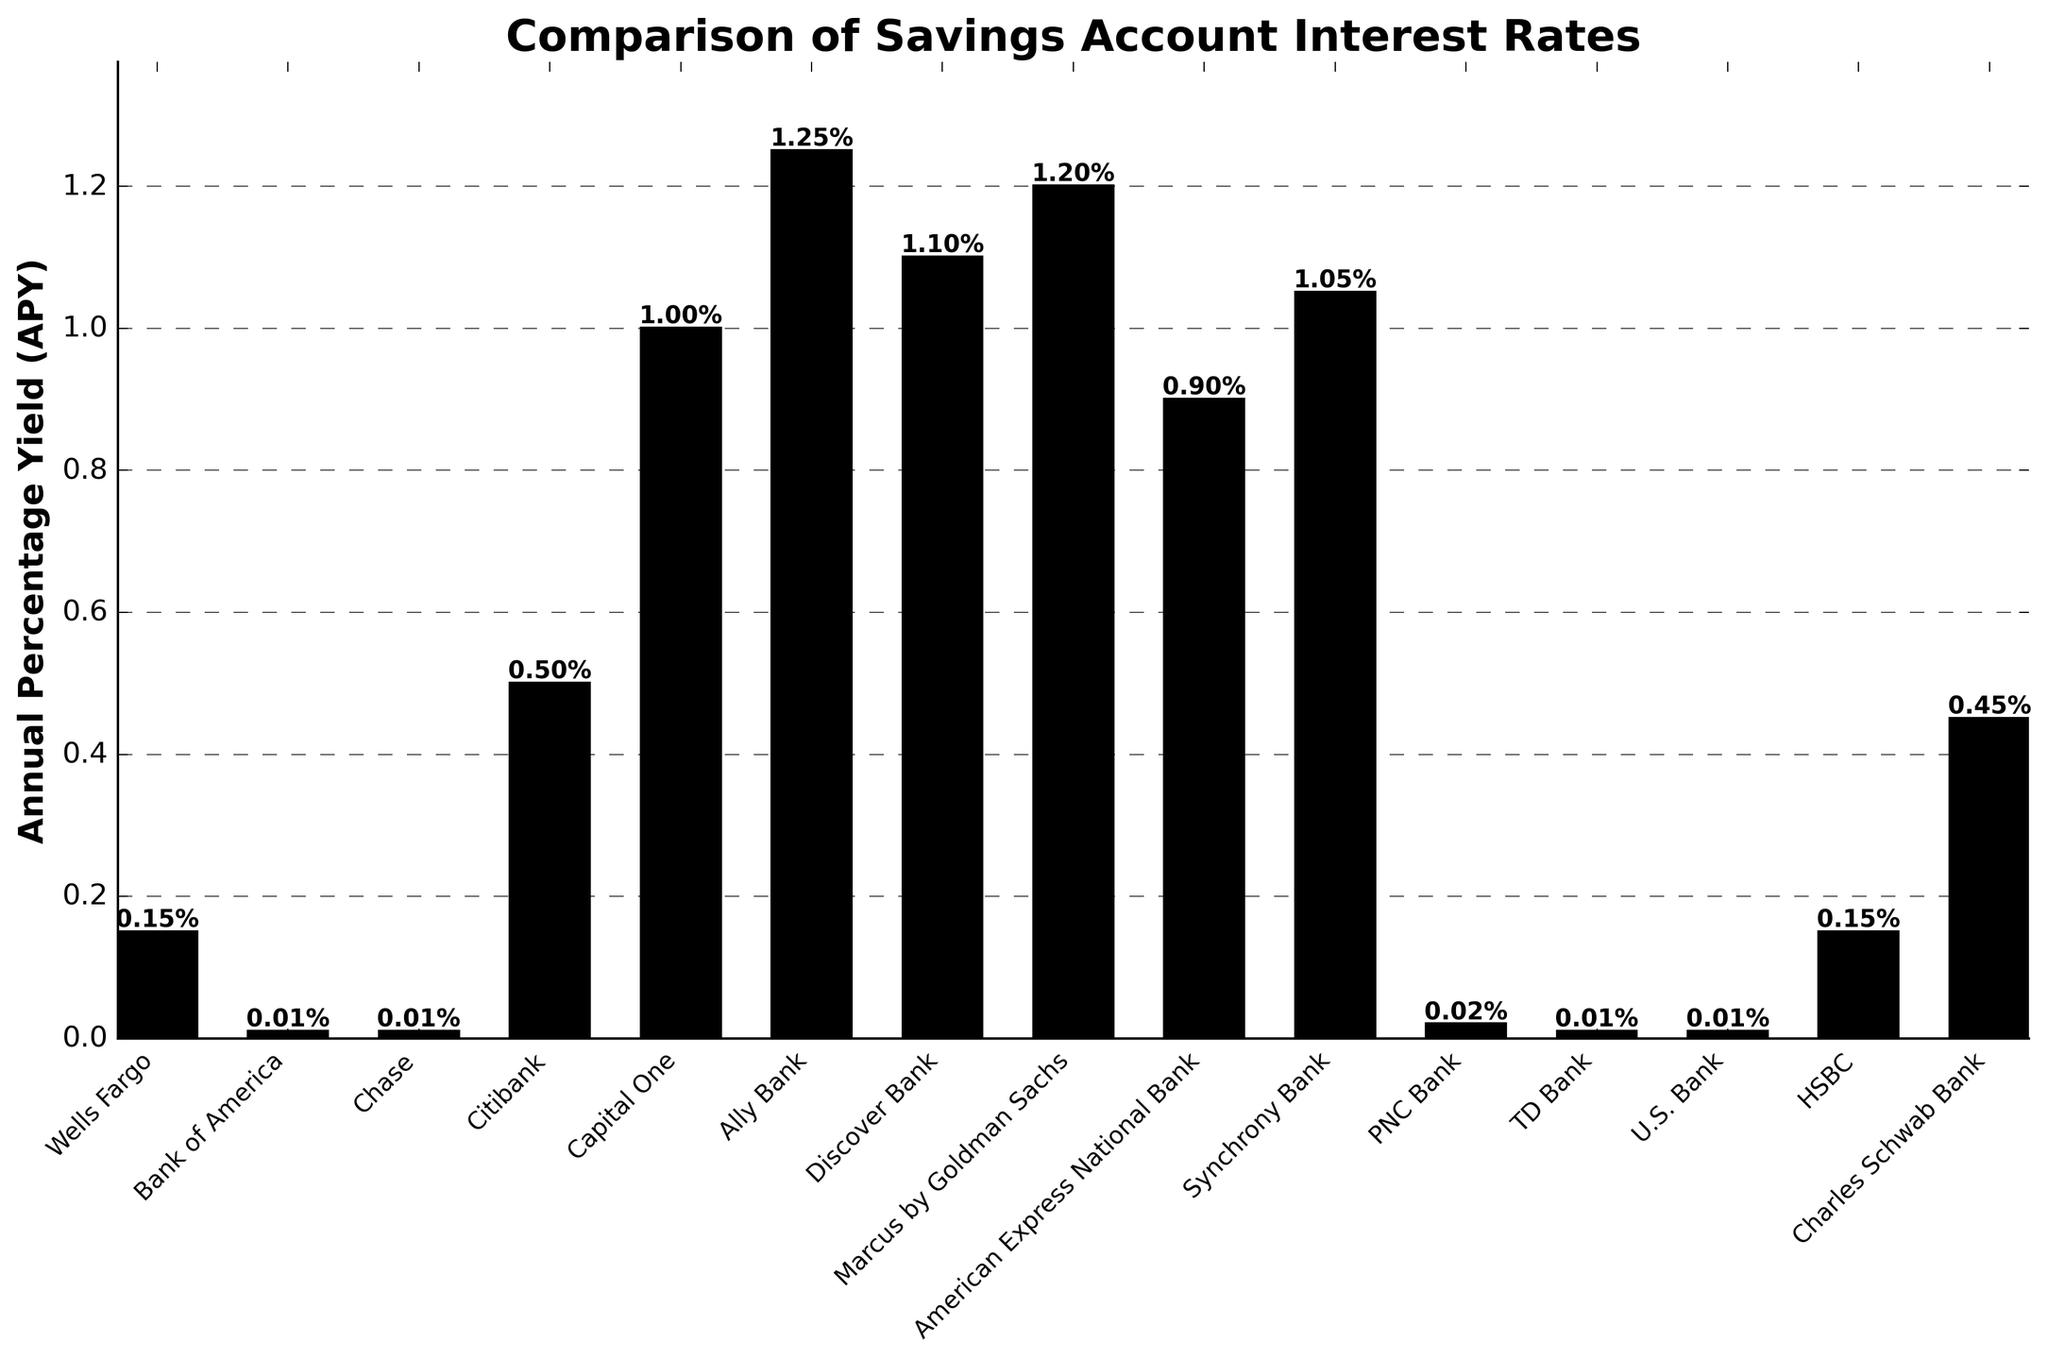What is the range of the Annual Percentage Yield (APY) among all the banks? To find the range, identify the highest and lowest APY values in the chart. The highest APY is 1.25% (Ally Bank), and the lowest is 0.01% (Bank of America, Chase, TD Bank, U.S. Bank). Subtract the lowest value from the highest value to get the range: 1.25% - 0.01% = 1.24%.
Answer: 1.24% Which bank offers the highest APY according to the chart? Look for the tallest bar on the figure which represents the highest APY. The tallest bar corresponds to Ally Bank with an APY of 1.25%.
Answer: Ally Bank How many banks have an APY lower than 0.10%? Identify the banks with bars representing APYs lower than 0.10%. Bank of America, Chase, TD Bank, and U.S. Bank all have an APY of 0.01%. PNC Bank has an APY of 0.02%. Therefore, there are 5 banks with an APY lower than 0.10%.
Answer: 5 What is the average APY of Capital One, Discover Bank, and Marcus by Goldman Sachs? Sum the APYs of Capital One (1.00%), Discover Bank (1.10%), and Marcus by Goldman Sachs (1.20%), then divide by the number of banks. (1.00 + 1.10 + 1.20) / 3 = 3.30 / 3 = 1.10%.
Answer: 1.10% Which banks have an APY equal to 0.01%? Examine the bars in the chart to find those that have an APY of 0.01%. Banks with 0.01% APY are Bank of America, Chase, TD Bank, and U.S. Bank.
Answer: Bank of America, Chase, TD Bank, U.S. Bank What's the difference in APY between the bank with the highest APY and the bank with the second lowest APY? Identify the highest APY (1.25% from Ally Bank) and the second lowest APY (0.02% from PNC Bank). Subtract the second lowest APY from the highest APY. 1.25% - 0.02% = 1.23%.
Answer: 1.23% How many banks have an APY of 1.00% or higher? Count the bars representing banks with an APY of 1.00% or higher. Capital One (1.00%), Ally Bank (1.25%), Discover Bank (1.10%), Marcus by Goldman Sachs (1.20%), and Synchrony Bank (1.05%) all meet this criterion. Thus, there are 5 banks.
Answer: 5 What is the median APY of all the banks in the chart? List all the APYs in ascending order: 0.01, 0.01, 0.01, 0.01, 0.02, 0.15, 0.15, 0.45, 0.50, 0.90, 1.00, 1.05, 1.10, 1.20, 1.25. The median value is the one in the middle of the ordered list. As there are 15 values, the median is the 8th value: 0.45%.
Answer: 0.45% Which bank offers twice the APY of Wells Fargo? Determine the APY of Wells Fargo which is 0.15%, and find twice this value (0.30%). Check the bar chart to see if any bank offers 0.30% APY. There is no bank offering exactly 0.30% APY according to the figure.
Answer: None 